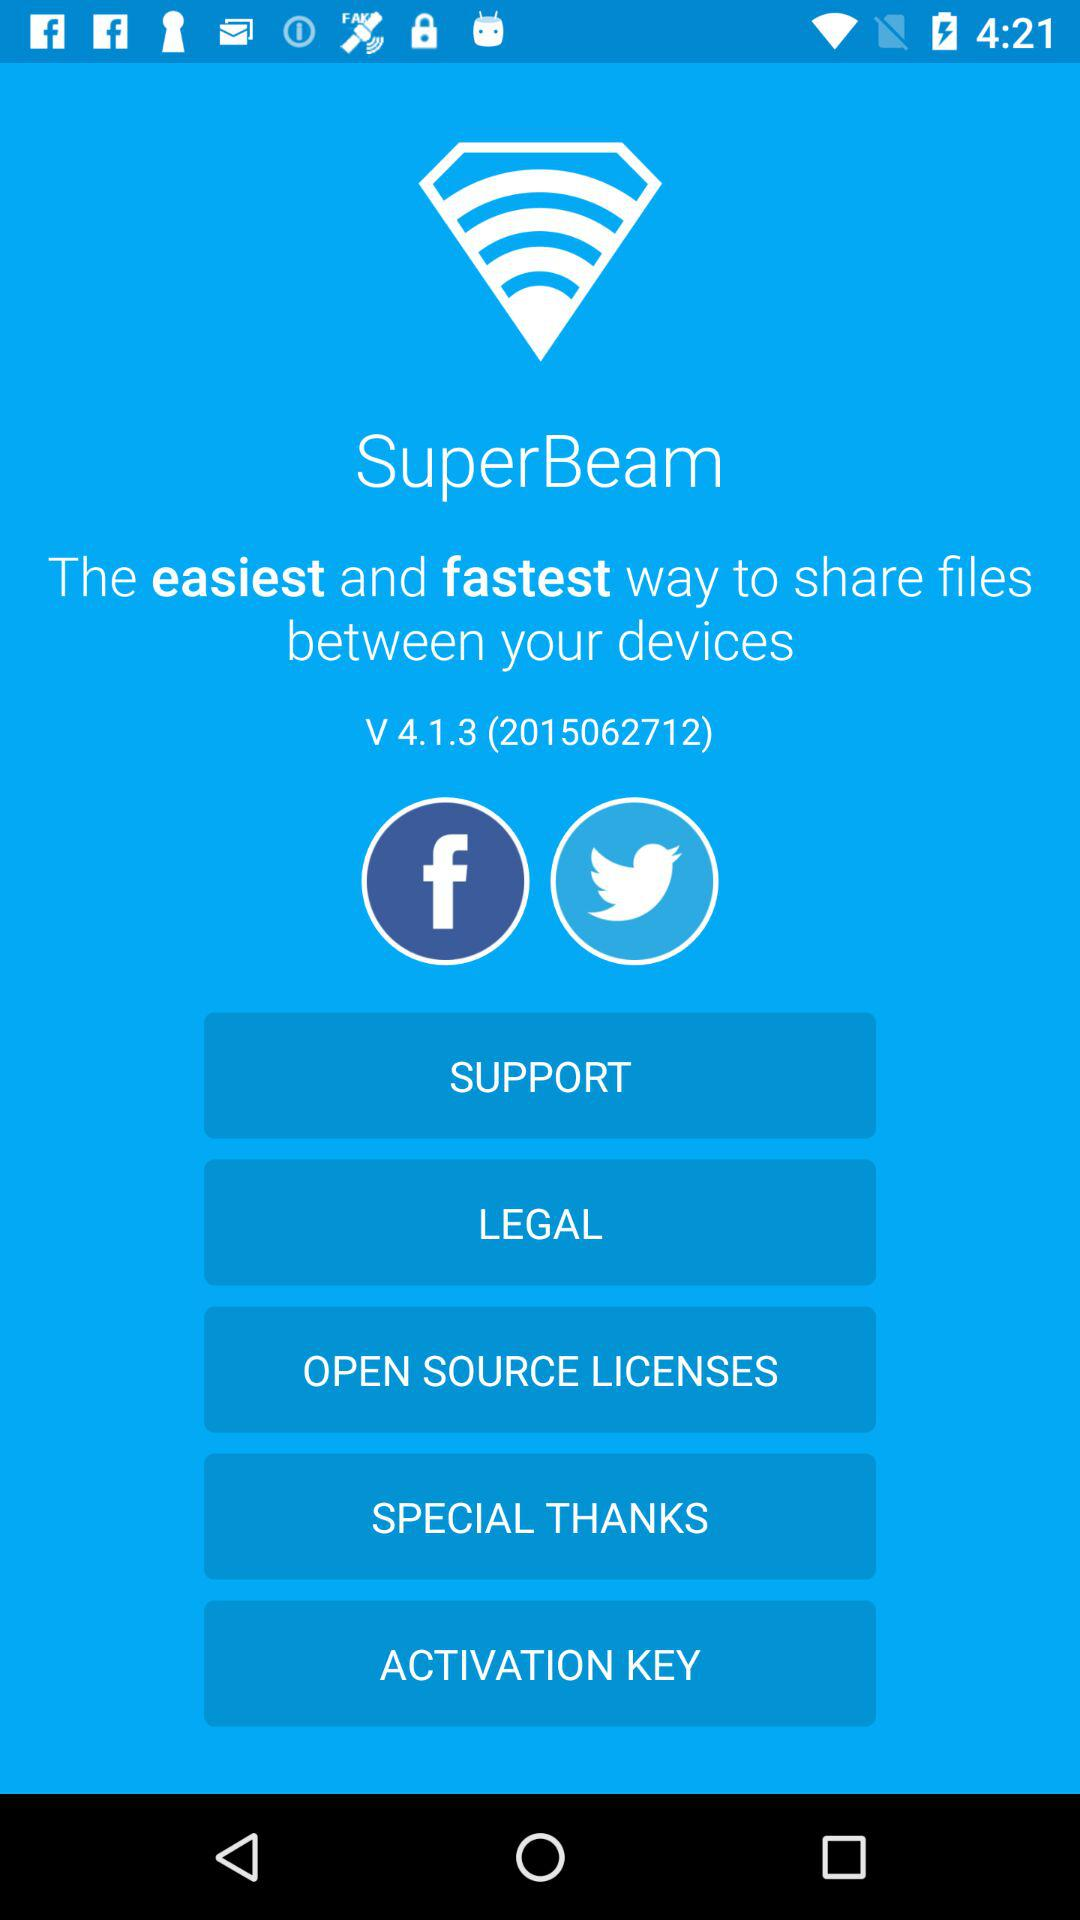What version is using? The version is 4.1.3 (2015062712). 